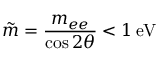Convert formula to latex. <formula><loc_0><loc_0><loc_500><loc_500>\tilde { m } = \frac { m _ { e e } } { \cos { 2 \theta } } < 1 \, e V</formula> 